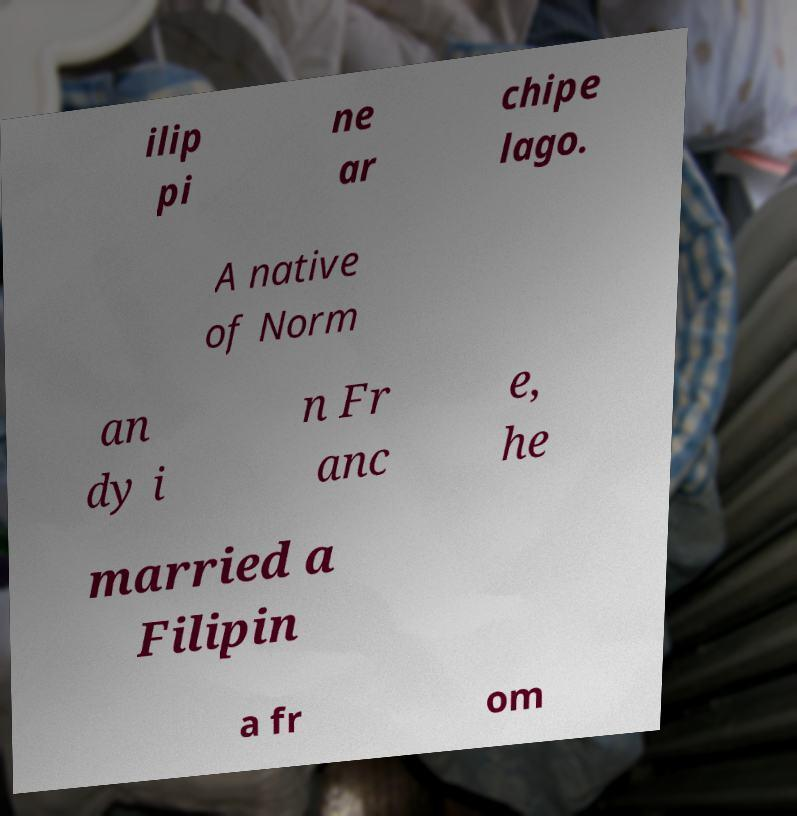What messages or text are displayed in this image? I need them in a readable, typed format. ilip pi ne ar chipe lago. A native of Norm an dy i n Fr anc e, he married a Filipin a fr om 